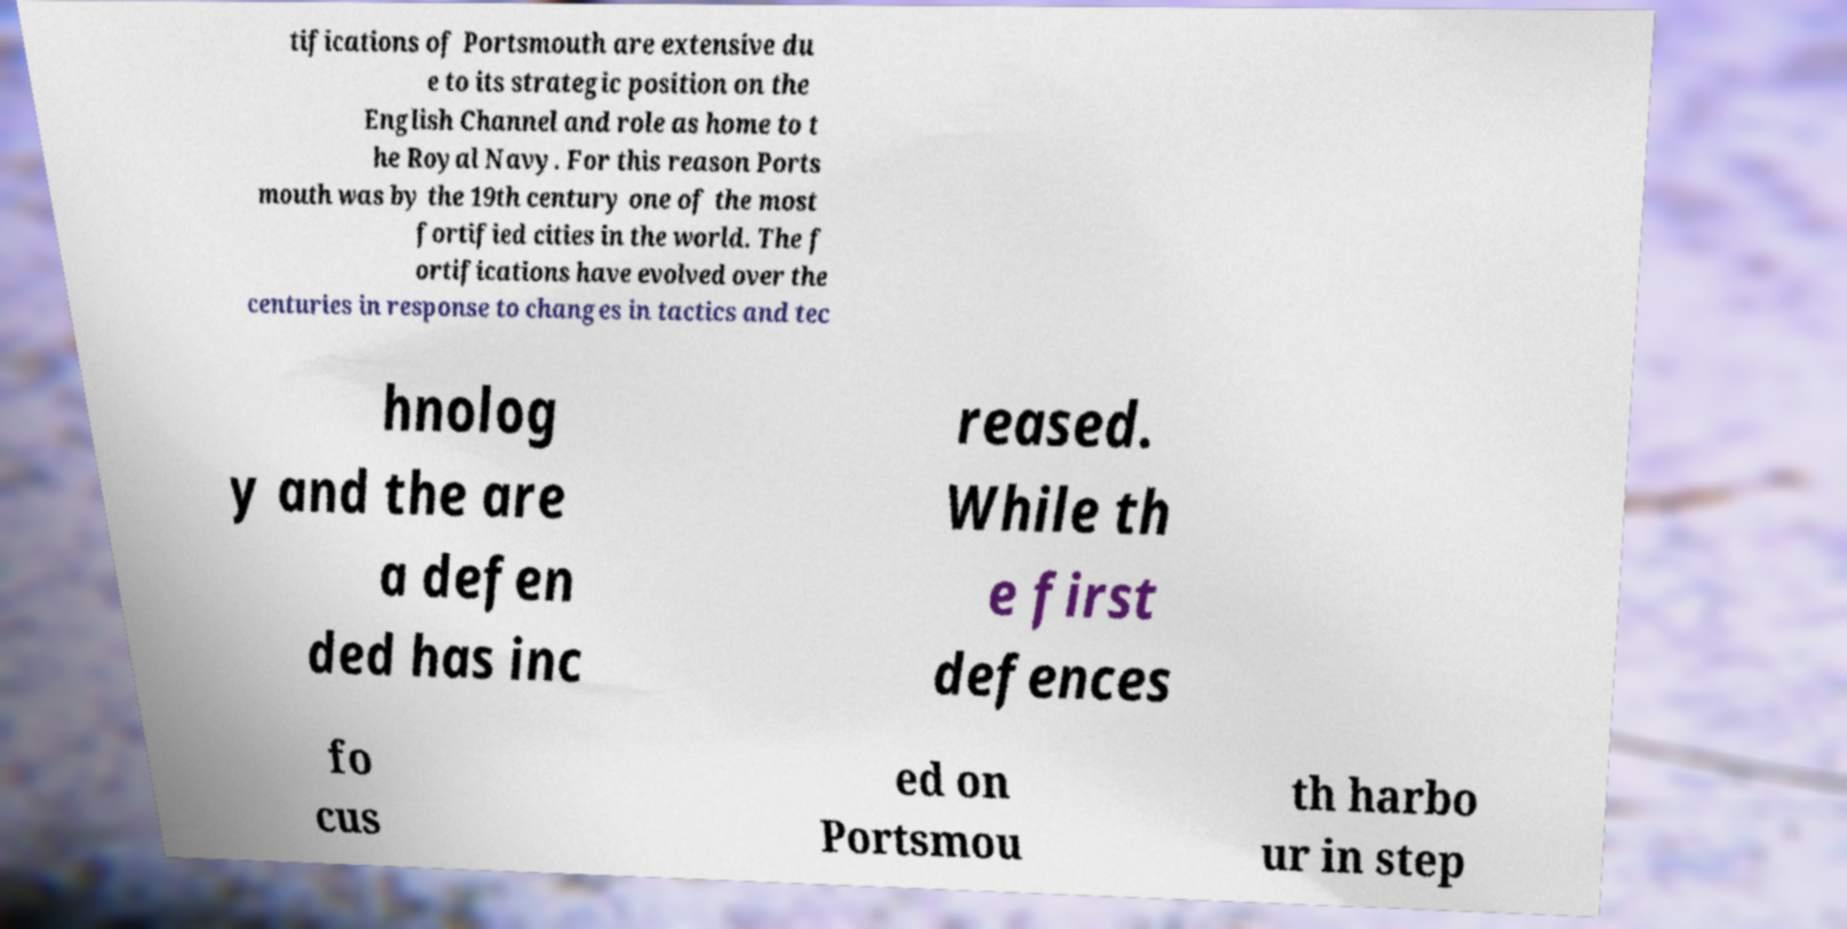I need the written content from this picture converted into text. Can you do that? tifications of Portsmouth are extensive du e to its strategic position on the English Channel and role as home to t he Royal Navy. For this reason Ports mouth was by the 19th century one of the most fortified cities in the world. The f ortifications have evolved over the centuries in response to changes in tactics and tec hnolog y and the are a defen ded has inc reased. While th e first defences fo cus ed on Portsmou th harbo ur in step 